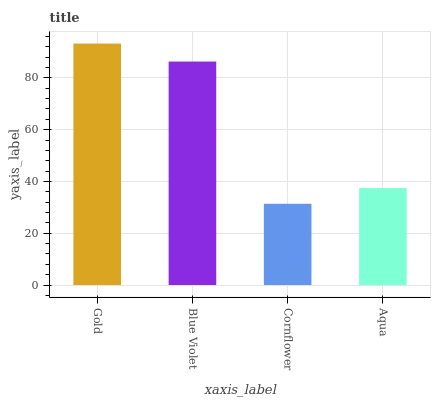Is Cornflower the minimum?
Answer yes or no. Yes. Is Gold the maximum?
Answer yes or no. Yes. Is Blue Violet the minimum?
Answer yes or no. No. Is Blue Violet the maximum?
Answer yes or no. No. Is Gold greater than Blue Violet?
Answer yes or no. Yes. Is Blue Violet less than Gold?
Answer yes or no. Yes. Is Blue Violet greater than Gold?
Answer yes or no. No. Is Gold less than Blue Violet?
Answer yes or no. No. Is Blue Violet the high median?
Answer yes or no. Yes. Is Aqua the low median?
Answer yes or no. Yes. Is Gold the high median?
Answer yes or no. No. Is Gold the low median?
Answer yes or no. No. 